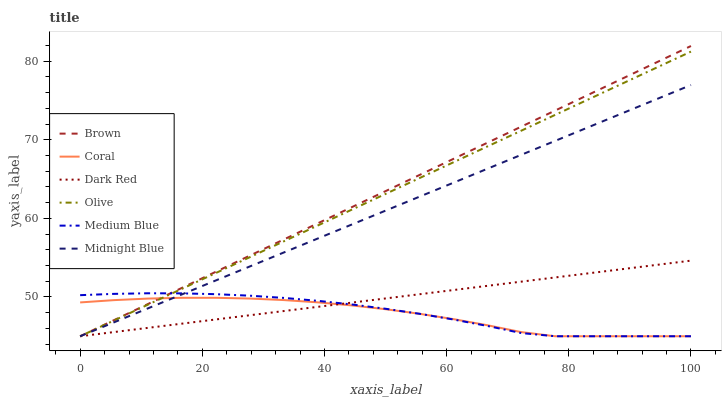Does Coral have the minimum area under the curve?
Answer yes or no. Yes. Does Brown have the maximum area under the curve?
Answer yes or no. Yes. Does Midnight Blue have the minimum area under the curve?
Answer yes or no. No. Does Midnight Blue have the maximum area under the curve?
Answer yes or no. No. Is Dark Red the smoothest?
Answer yes or no. Yes. Is Coral the roughest?
Answer yes or no. Yes. Is Midnight Blue the smoothest?
Answer yes or no. No. Is Midnight Blue the roughest?
Answer yes or no. No. Does Brown have the lowest value?
Answer yes or no. Yes. Does Brown have the highest value?
Answer yes or no. Yes. Does Midnight Blue have the highest value?
Answer yes or no. No. Does Coral intersect Midnight Blue?
Answer yes or no. Yes. Is Coral less than Midnight Blue?
Answer yes or no. No. Is Coral greater than Midnight Blue?
Answer yes or no. No. 